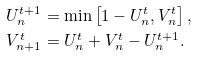<formula> <loc_0><loc_0><loc_500><loc_500>U _ { n } ^ { t + 1 } & = \min \left [ 1 - U _ { n } ^ { t } , V _ { n } ^ { t } \right ] , \\ V _ { n + 1 } ^ { t } & = U _ { n } ^ { t } + V _ { n } ^ { t } - U _ { n } ^ { t + 1 } .</formula> 